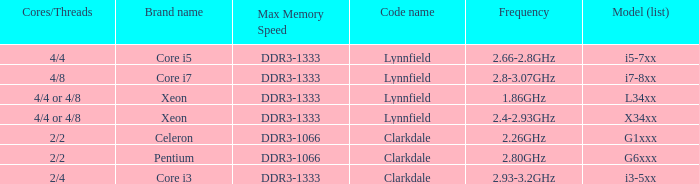List the number of cores for ddr3-1333 with frequencies between 2.66-2.8ghz. 4/4. 